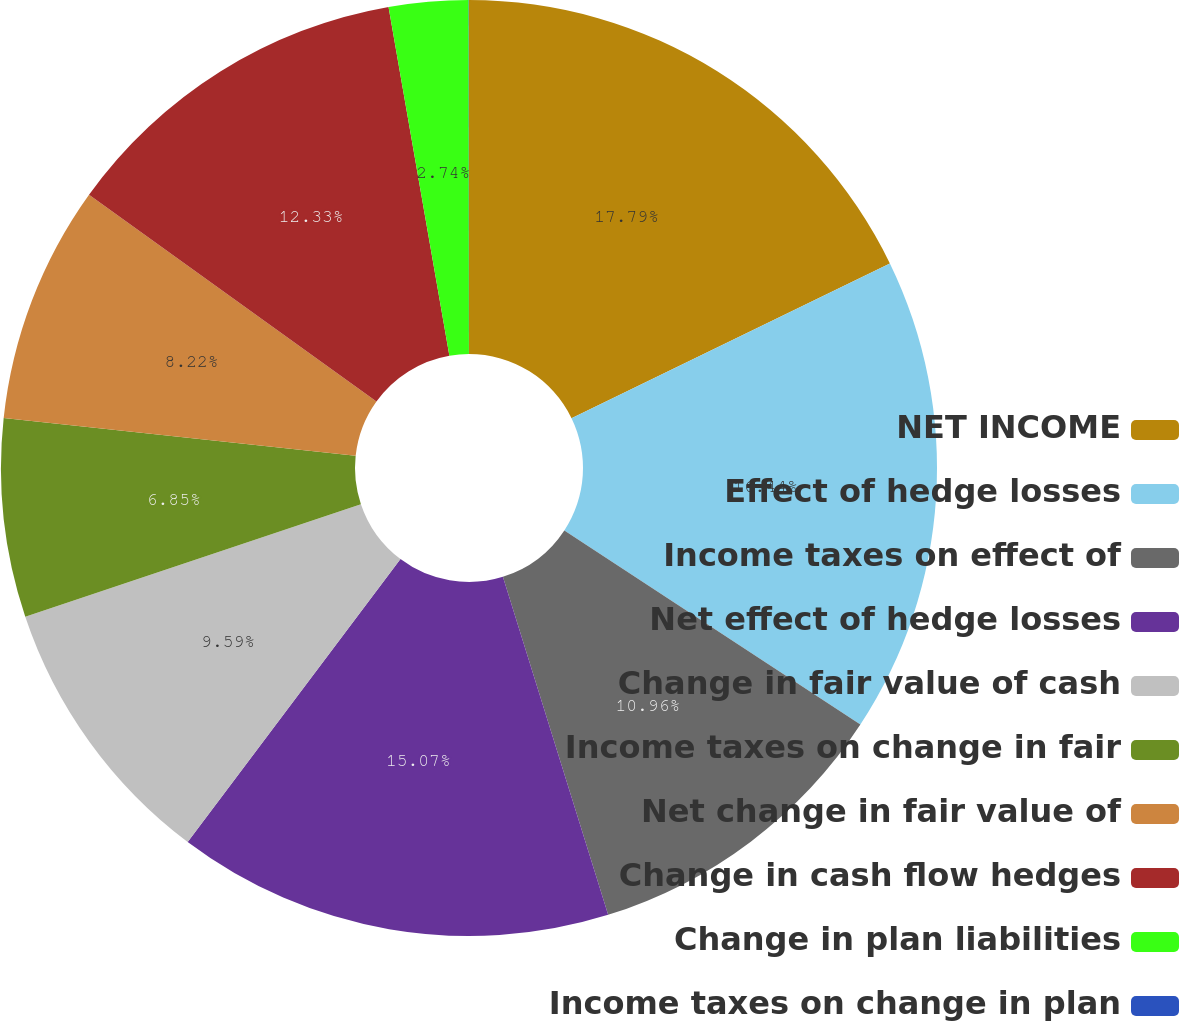<chart> <loc_0><loc_0><loc_500><loc_500><pie_chart><fcel>NET INCOME<fcel>Effect of hedge losses<fcel>Income taxes on effect of<fcel>Net effect of hedge losses<fcel>Change in fair value of cash<fcel>Income taxes on change in fair<fcel>Net change in fair value of<fcel>Change in cash flow hedges<fcel>Change in plan liabilities<fcel>Income taxes on change in plan<nl><fcel>17.8%<fcel>16.44%<fcel>10.96%<fcel>15.07%<fcel>9.59%<fcel>6.85%<fcel>8.22%<fcel>12.33%<fcel>2.74%<fcel>0.01%<nl></chart> 